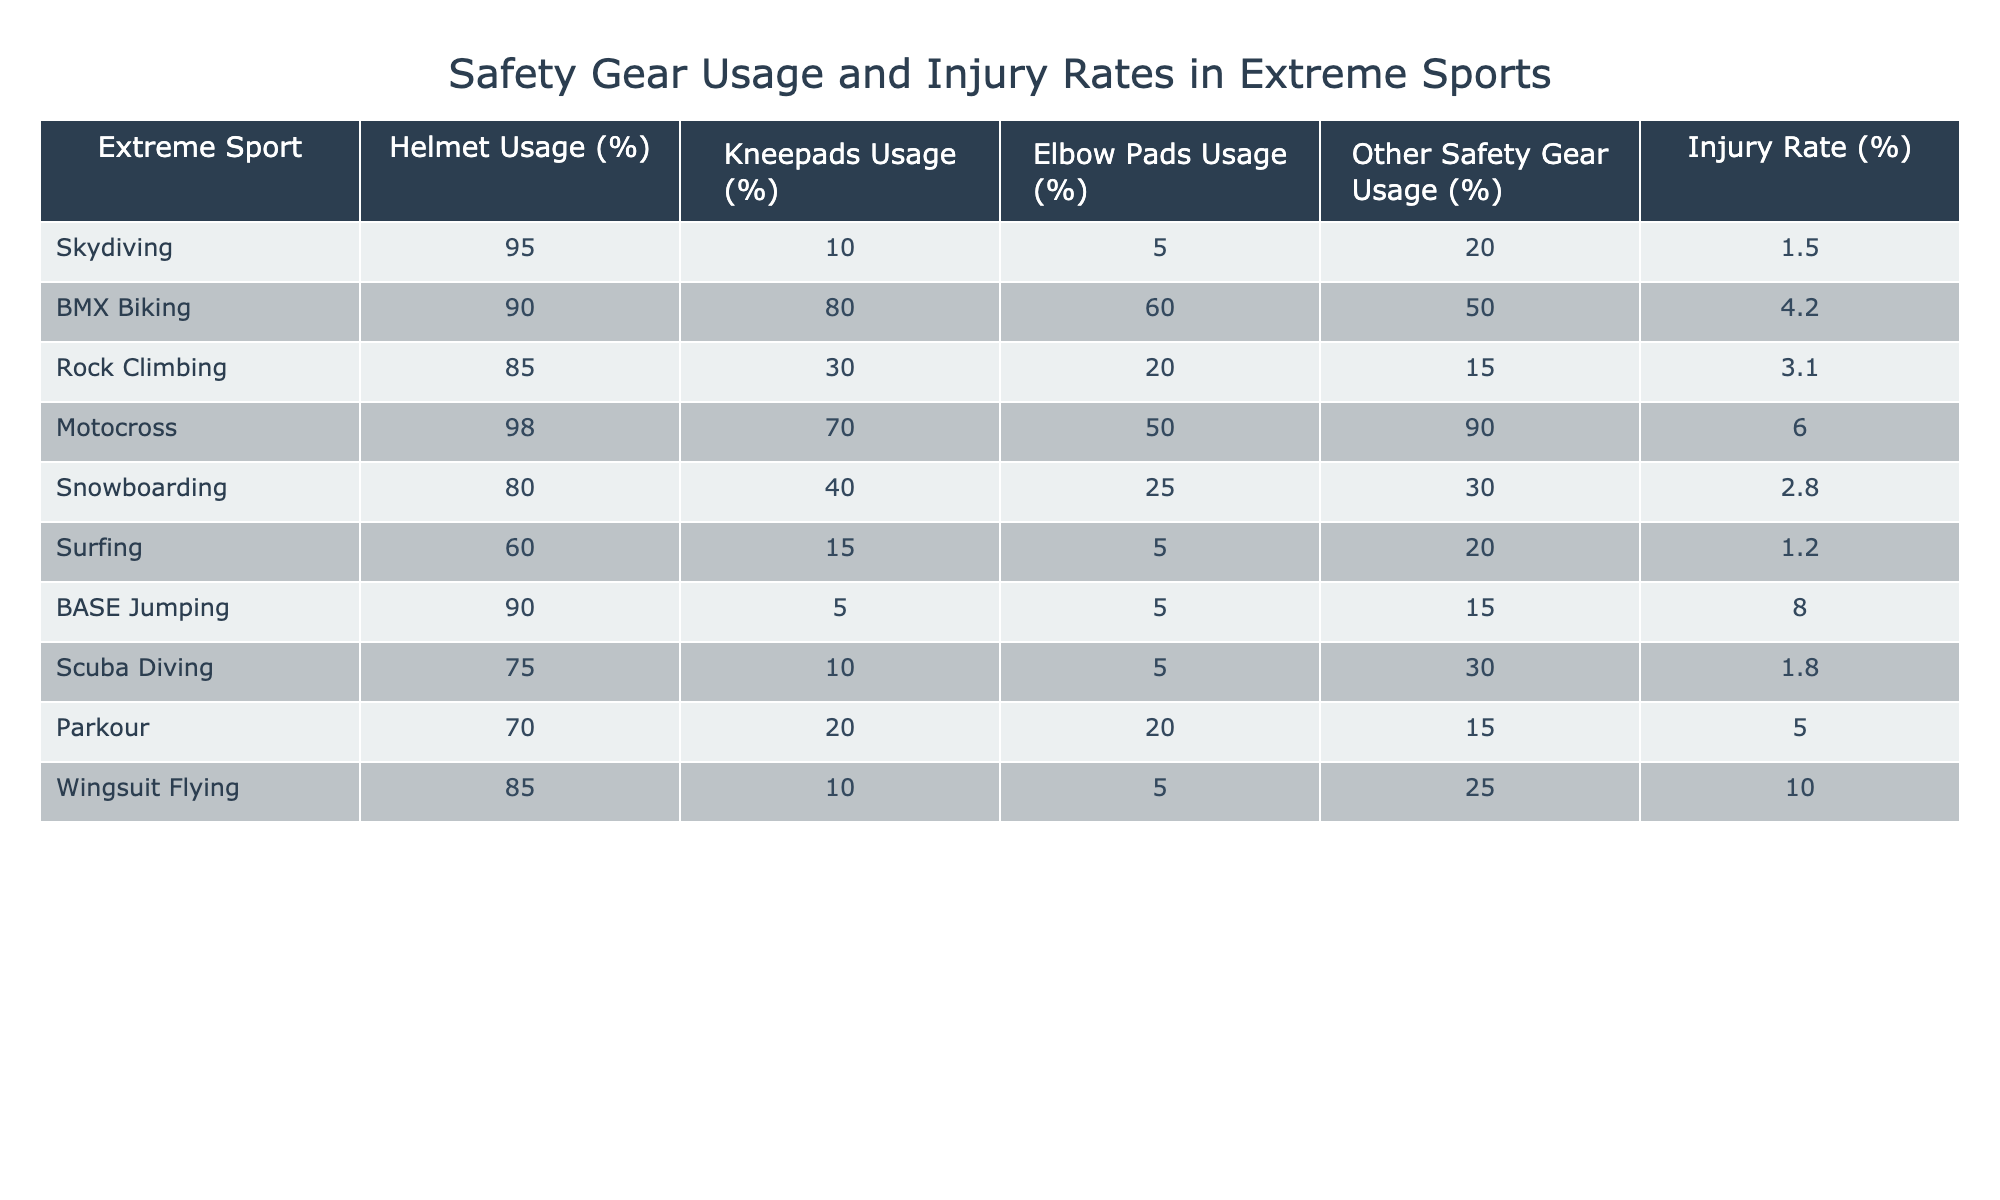What is the helmet usage percentage for BMX biking? The table directly lists the helmet usage percentage for BMX biking as 90%.
Answer: 90% Which extreme sport has the highest injury rate? Looking at the 'Injury Rate (%)' column, BASE Jumping has the highest value at 8%.
Answer: 8% What is the average knee pad usage percentage across all extreme sports? To find the average, sum the knee pad usage percentages: (10 + 80 + 30 + 70 + 40 + 15 + 5 + 10 + 20 + 10) = 300. There are 10 sports, so the average is 300/10 = 30%.
Answer: 30% Is the elbow pad usage percentage for motocross higher than that for snowboarding? The elbow pad usage for motocross is 50%, while for snowboarding, it is 25%. Since 50% is greater than 25%, the statement is true.
Answer: Yes How much higher is the helmet usage percentage for skydiving compared to that of surfing? The helmet usage for skydiving is 95% and for surfing is 60%. The difference is 95 - 60 = 35%.
Answer: 35% Which sport has the lowest percentage of other safety gear usage? The table shows that BASE Jumping has the lowest percentage of other safety gear usage at 15%.
Answer: 15% What percentage of motocross participants use kneepads compared to those using elbow pads? For motocross, 70% use kneepads and 50% use elbow pads. Kneepads usage is higher by 20%, calculated as 70 - 50 = 20%.
Answer: 20% Is surfing less dangerous than snowboarding based on their injury rates? Surfing has an injury rate of 1.2%, and snowboarding has 2.8%. Since 1.2% is less than 2.8%, surfing is indeed less dangerous based on these rates.
Answer: Yes Which sport has the highest usage of other safety gear, and what is the percentage? Looking at the 'Other Safety Gear Usage (%)' column, motocross has the highest percentage at 90%.
Answer: 90% 